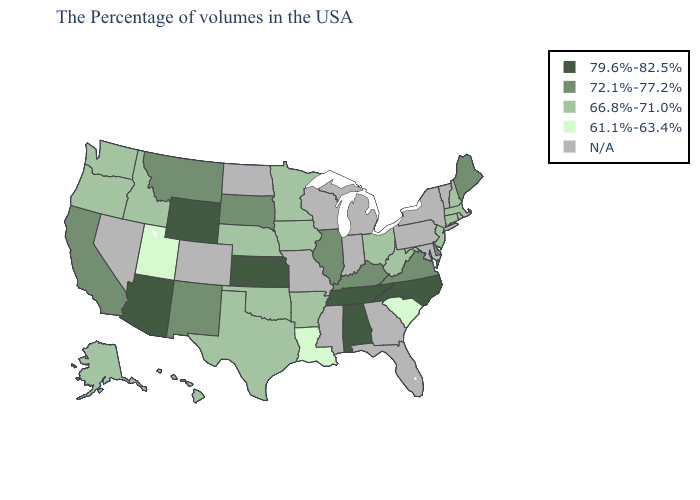Name the states that have a value in the range 72.1%-77.2%?
Give a very brief answer. Maine, Delaware, Virginia, Kentucky, Illinois, South Dakota, New Mexico, Montana, California. Name the states that have a value in the range 79.6%-82.5%?
Short answer required. North Carolina, Alabama, Tennessee, Kansas, Wyoming, Arizona. Which states hav the highest value in the Northeast?
Give a very brief answer. Maine. Name the states that have a value in the range 61.1%-63.4%?
Quick response, please. South Carolina, Louisiana, Utah. What is the value of North Dakota?
Quick response, please. N/A. Which states have the highest value in the USA?
Give a very brief answer. North Carolina, Alabama, Tennessee, Kansas, Wyoming, Arizona. Which states have the lowest value in the West?
Quick response, please. Utah. Which states have the lowest value in the USA?
Concise answer only. South Carolina, Louisiana, Utah. Does Maine have the highest value in the Northeast?
Write a very short answer. Yes. How many symbols are there in the legend?
Short answer required. 5. Name the states that have a value in the range 79.6%-82.5%?
Be succinct. North Carolina, Alabama, Tennessee, Kansas, Wyoming, Arizona. What is the lowest value in states that border Minnesota?
Answer briefly. 66.8%-71.0%. Name the states that have a value in the range 72.1%-77.2%?
Answer briefly. Maine, Delaware, Virginia, Kentucky, Illinois, South Dakota, New Mexico, Montana, California. What is the value of Indiana?
Short answer required. N/A. 